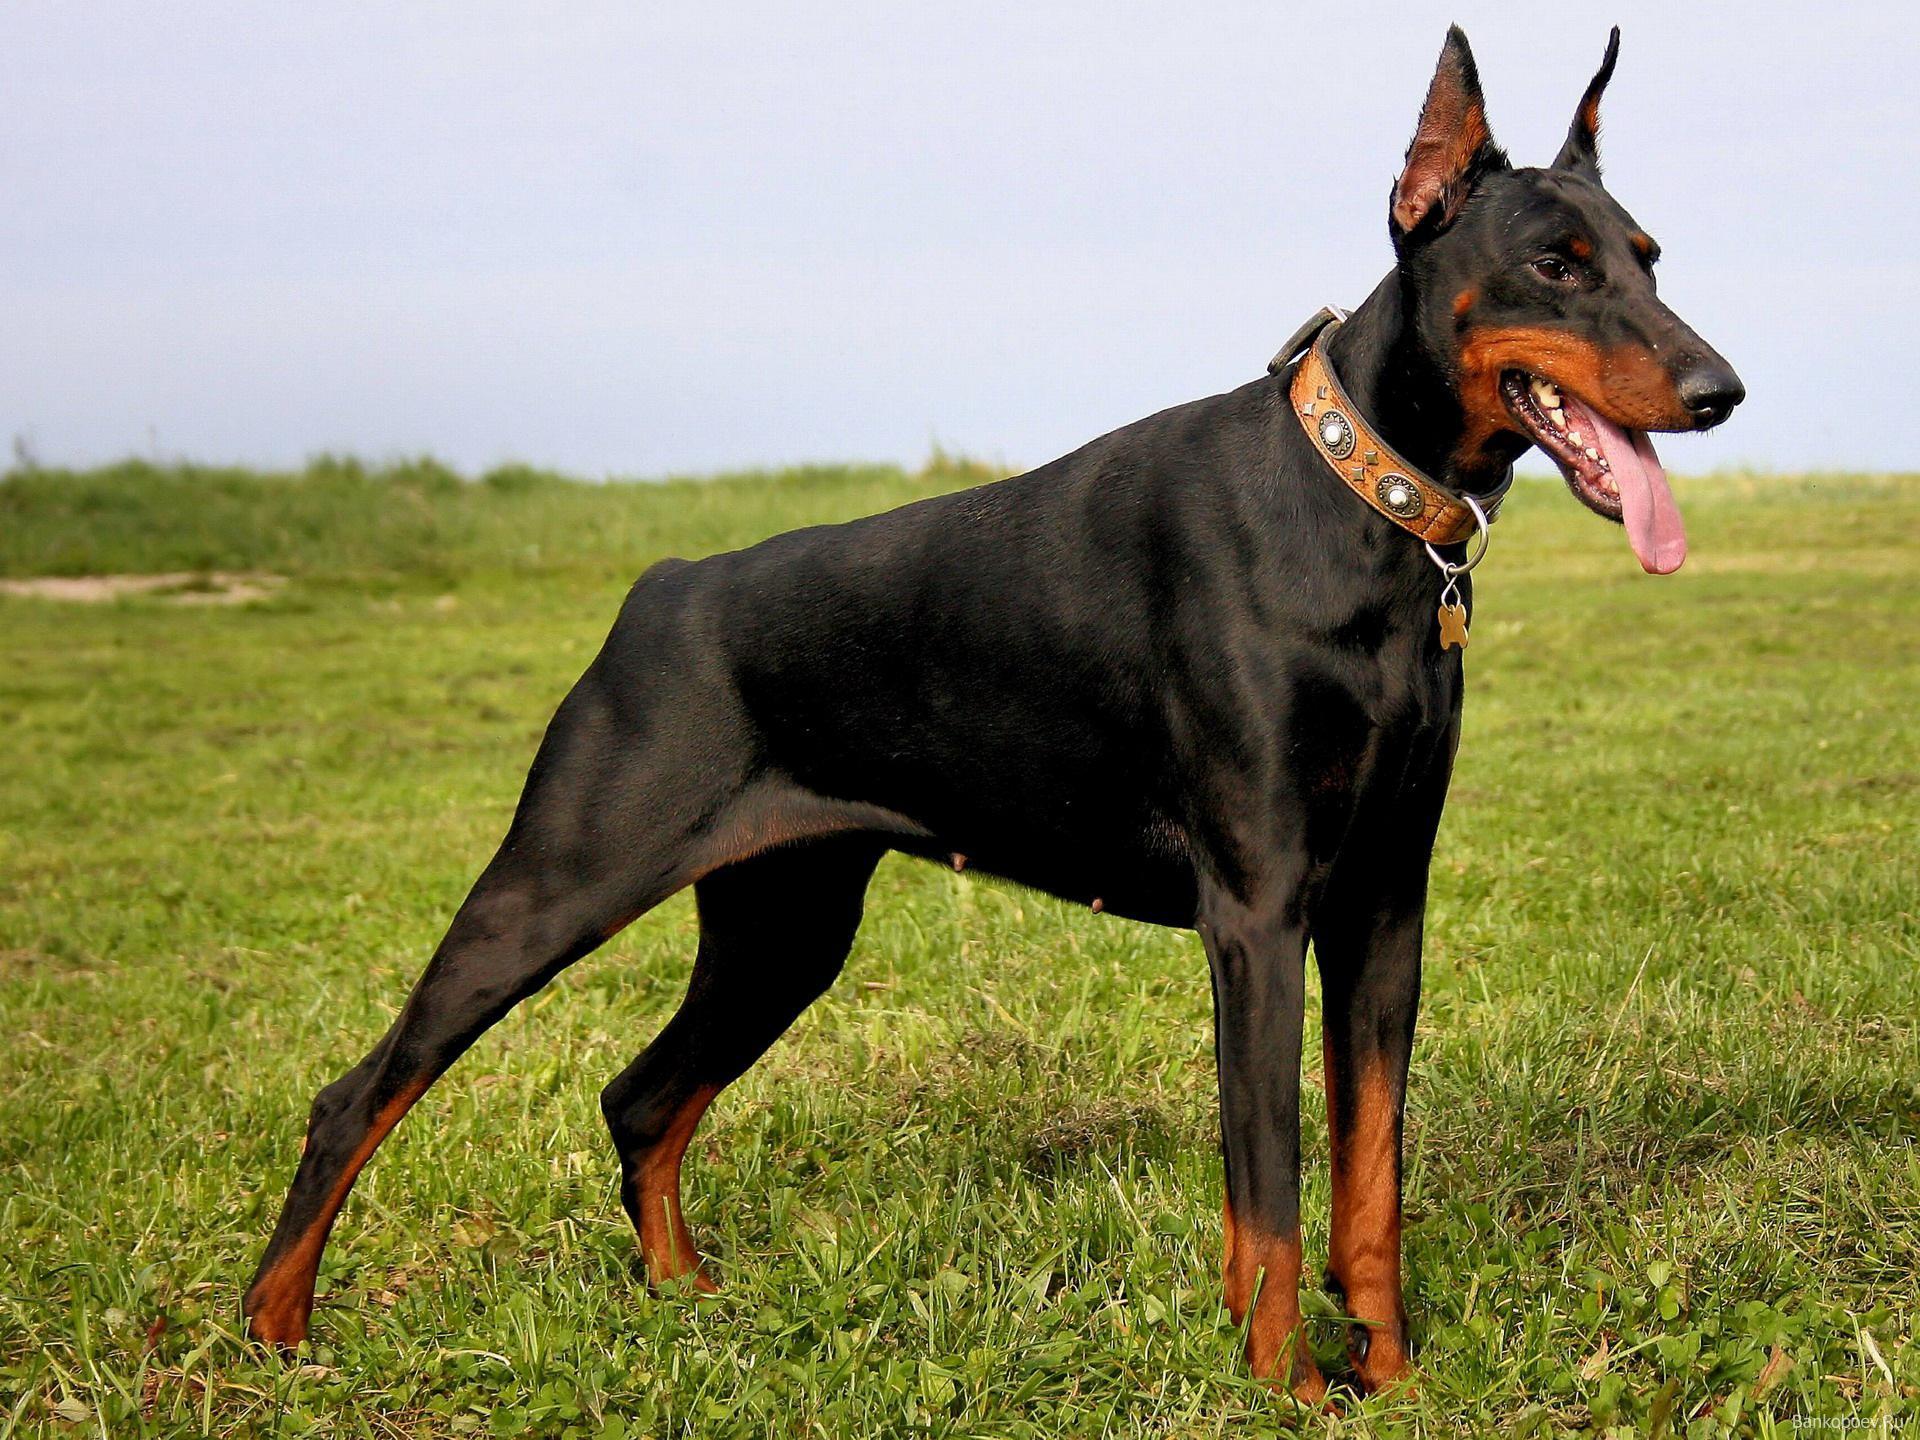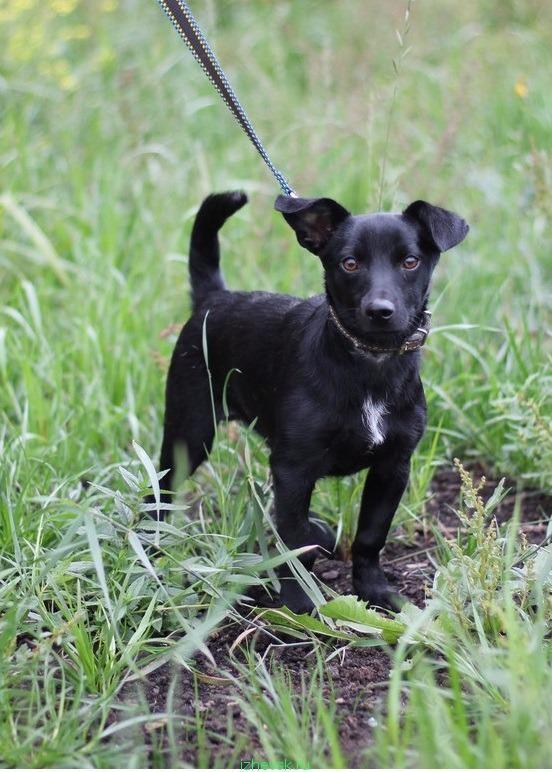The first image is the image on the left, the second image is the image on the right. Analyze the images presented: Is the assertion "The dog in the image on the left is wearing a collar and hanging its tongue out." valid? Answer yes or no. Yes. The first image is the image on the left, the second image is the image on the right. Examine the images to the left and right. Is the description "Each image features one adult doberman with erect ears and upright head, and the dog on the left wears something spiky around its neck." accurate? Answer yes or no. No. 